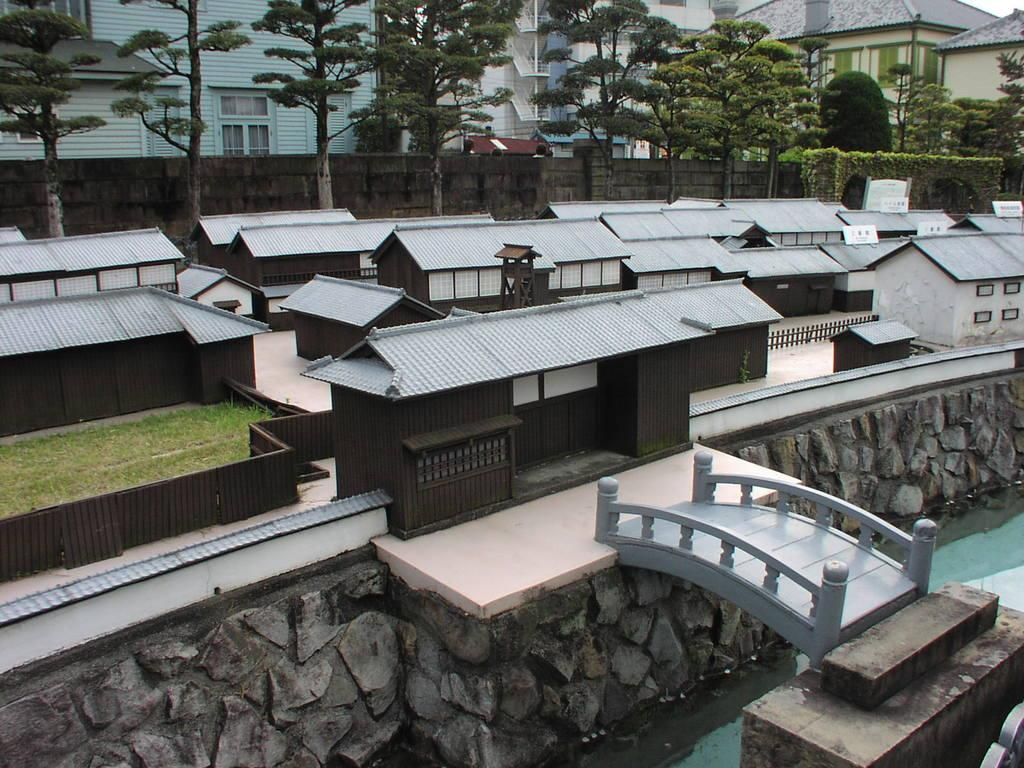What type of objects are in the image? There are miniatures in the image. What type of natural elements are in the image? There are trees in the image. What type of man-made structures are in the image? There are buildings in the image. What type of nose can be seen on the miniatures in the image? There are no noses present on the miniatures in the image, as they are likely inanimate objects. What type of toothpaste is used by the trees in the image? There are no toothpaste references in the image, as trees are living organisms and not capable of using toothpaste. 